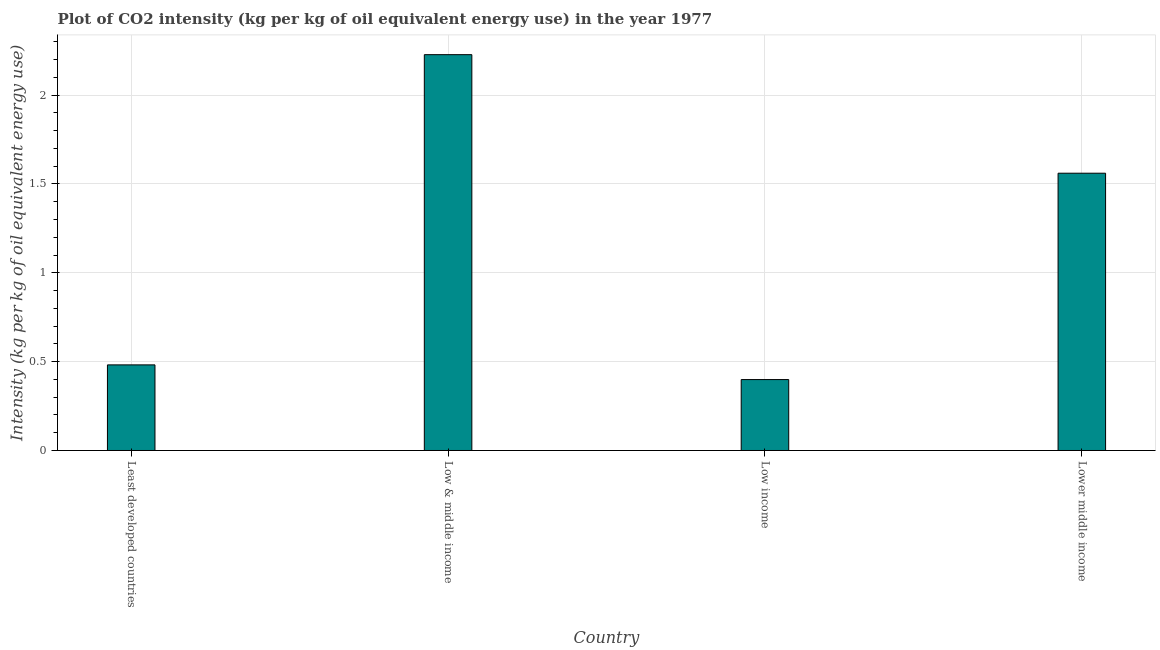Does the graph contain any zero values?
Your response must be concise. No. What is the title of the graph?
Your response must be concise. Plot of CO2 intensity (kg per kg of oil equivalent energy use) in the year 1977. What is the label or title of the Y-axis?
Offer a terse response. Intensity (kg per kg of oil equivalent energy use). What is the co2 intensity in Lower middle income?
Offer a very short reply. 1.56. Across all countries, what is the maximum co2 intensity?
Provide a succinct answer. 2.23. Across all countries, what is the minimum co2 intensity?
Give a very brief answer. 0.4. What is the sum of the co2 intensity?
Your answer should be very brief. 4.67. What is the difference between the co2 intensity in Low & middle income and Lower middle income?
Offer a very short reply. 0.67. What is the average co2 intensity per country?
Your answer should be very brief. 1.17. What is the median co2 intensity?
Provide a short and direct response. 1.02. What is the ratio of the co2 intensity in Low income to that in Lower middle income?
Your response must be concise. 0.26. Is the co2 intensity in Low & middle income less than that in Low income?
Provide a succinct answer. No. What is the difference between the highest and the second highest co2 intensity?
Give a very brief answer. 0.67. Is the sum of the co2 intensity in Least developed countries and Low & middle income greater than the maximum co2 intensity across all countries?
Ensure brevity in your answer.  Yes. What is the difference between the highest and the lowest co2 intensity?
Your answer should be compact. 1.83. How many bars are there?
Your response must be concise. 4. Are all the bars in the graph horizontal?
Provide a succinct answer. No. What is the difference between two consecutive major ticks on the Y-axis?
Make the answer very short. 0.5. Are the values on the major ticks of Y-axis written in scientific E-notation?
Your answer should be very brief. No. What is the Intensity (kg per kg of oil equivalent energy use) in Least developed countries?
Your answer should be compact. 0.48. What is the Intensity (kg per kg of oil equivalent energy use) in Low & middle income?
Offer a terse response. 2.23. What is the Intensity (kg per kg of oil equivalent energy use) in Low income?
Offer a terse response. 0.4. What is the Intensity (kg per kg of oil equivalent energy use) in Lower middle income?
Give a very brief answer. 1.56. What is the difference between the Intensity (kg per kg of oil equivalent energy use) in Least developed countries and Low & middle income?
Your response must be concise. -1.75. What is the difference between the Intensity (kg per kg of oil equivalent energy use) in Least developed countries and Low income?
Offer a very short reply. 0.08. What is the difference between the Intensity (kg per kg of oil equivalent energy use) in Least developed countries and Lower middle income?
Give a very brief answer. -1.08. What is the difference between the Intensity (kg per kg of oil equivalent energy use) in Low & middle income and Low income?
Offer a terse response. 1.83. What is the difference between the Intensity (kg per kg of oil equivalent energy use) in Low & middle income and Lower middle income?
Keep it short and to the point. 0.67. What is the difference between the Intensity (kg per kg of oil equivalent energy use) in Low income and Lower middle income?
Offer a very short reply. -1.16. What is the ratio of the Intensity (kg per kg of oil equivalent energy use) in Least developed countries to that in Low & middle income?
Provide a succinct answer. 0.22. What is the ratio of the Intensity (kg per kg of oil equivalent energy use) in Least developed countries to that in Low income?
Your answer should be very brief. 1.21. What is the ratio of the Intensity (kg per kg of oil equivalent energy use) in Least developed countries to that in Lower middle income?
Provide a succinct answer. 0.31. What is the ratio of the Intensity (kg per kg of oil equivalent energy use) in Low & middle income to that in Low income?
Offer a terse response. 5.58. What is the ratio of the Intensity (kg per kg of oil equivalent energy use) in Low & middle income to that in Lower middle income?
Provide a short and direct response. 1.43. What is the ratio of the Intensity (kg per kg of oil equivalent energy use) in Low income to that in Lower middle income?
Offer a terse response. 0.26. 